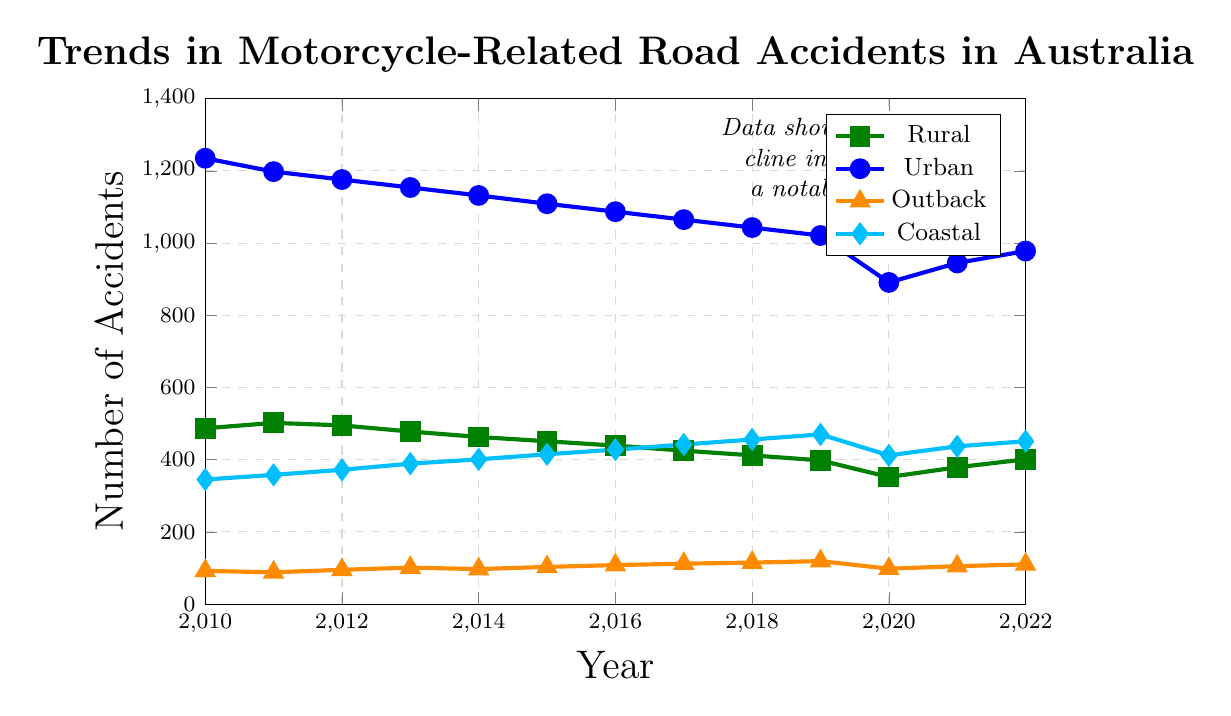What is the trend for Rural Motorcycle Accidents from 2010 to 2022? The trend for Rural Motorcycle Accidents can be identified by examining the slope of the line representing rural data points from 2010 to 2022. The number of accidents starts at 487 in 2010 and decreases to 401 by 2022, with some fluctuations. This indicates a general downward trend.
Answer: Downward Which year had the lowest number of Urban Motorcycle Accidents? To find the year with the lowest number of Urban Motorcycle Accidents, look for the minimum point on the urban line plot. The lowest point is at 2020 with 891 accidents.
Answer: 2020 In which year did Coastal Road Accidents see a notable increase after a previous dip? Identify the dip and subsequent increase in Coastal Road Accidents by tracking the coordinates on the coastal line plot. The number of accidents decreased to 412 in 2020 and then increased noticeably to 437 in the following year, 2021.
Answer: 2021 How do the Outback Accidents compare between 2010 and 2022? To compare the Outback Accidents between 2010 and 2022, check the values at these years on the outback line plot. In 2010, there were 92 accidents, and in 2022, there were 110 accidents. This indicates an increase.
Answer: Increased What is the average number of Urban Motorcycle Accidents over the entire period? Calculate the average by summing the Urban Motorcycle Accidents for each year and dividing by the number of years. (1235 + 1198 + 1176 + 1154 + 1132 + 1109 + 1087 + 1065 + 1043 + 1021 + 891 + 945 + 978) / 13 = 1071.5
Answer: 1071.5 Which type of road accident had the most stable trend, showing the least variability over the years? Assess the stability of each accident trend by visually examining the consistency of the lines for each category. The Outback Accidents line shows the least variability, fluctuating only slightly over the years.
Answer: Outback Accidents By how much did Rural Motorcycle Accidents decrease from 2010 to 2020? Calculate the decrease by subtracting the 2020 value from the 2010 value for Rural Motorcycle Accidents. 487 - 352 = 135
Answer: 135 Compare the highest value of Coastal Road Accidents to the lowest value of Urban Motorcycle Accidents. Identify the highest value of Coastal Road Accidents (470 in 2019) and the lowest value of Urban Motorcycle Accidents (891 in 2020). Compare these two values. 470 < 891, so Coastal Road Accidents at its highest are still lower than Urban Motorcycle Accidents at their lowest.
Answer: Coastal Road Accidents are lower What is the general shape of the trends for Coastal Road Accidents from 2010 to 2022? Describe the overall pattern by examining the slope of the coastal line plot. The trend shows a general increase, with a peak in 2019, a dip in 2020, and a rise again until 2022.
Answer: Increasing with fluctuations Compared to 2010, how did Urban Motorcycle Accidents change by the end of the period in 2022? To determine the change, subtract the number of Urban Motorcycle Accidents in 2022 from the number in 2010. 1235 - 978 = 257, indicating a decrease.
Answer: Decreased by 257 